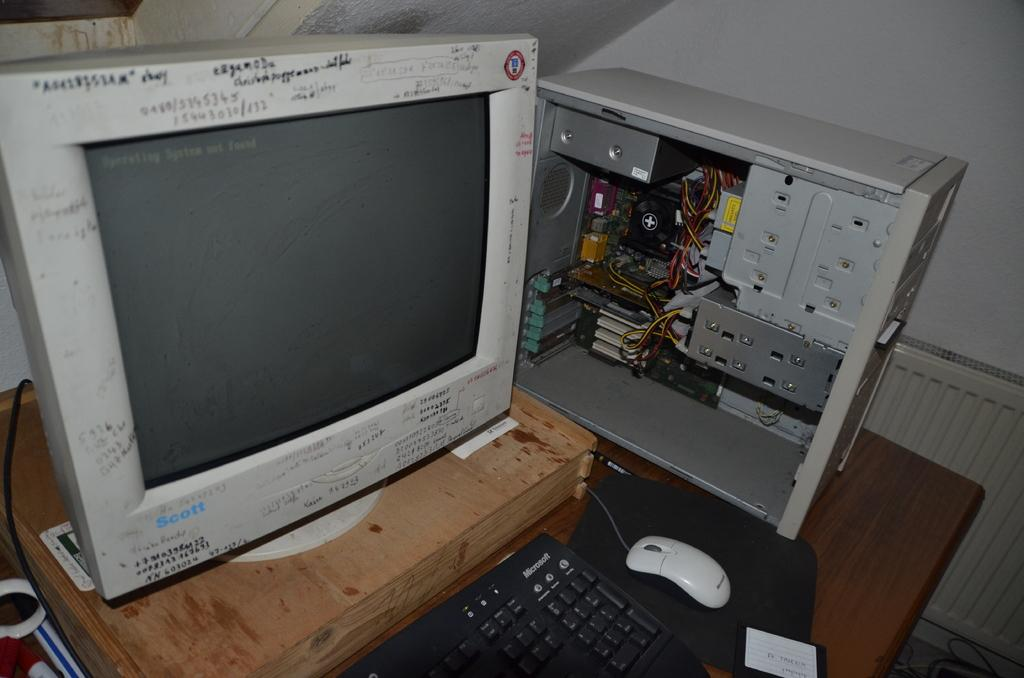<image>
Write a terse but informative summary of the picture. A PC monitor with the word "scott" on it in blue. 